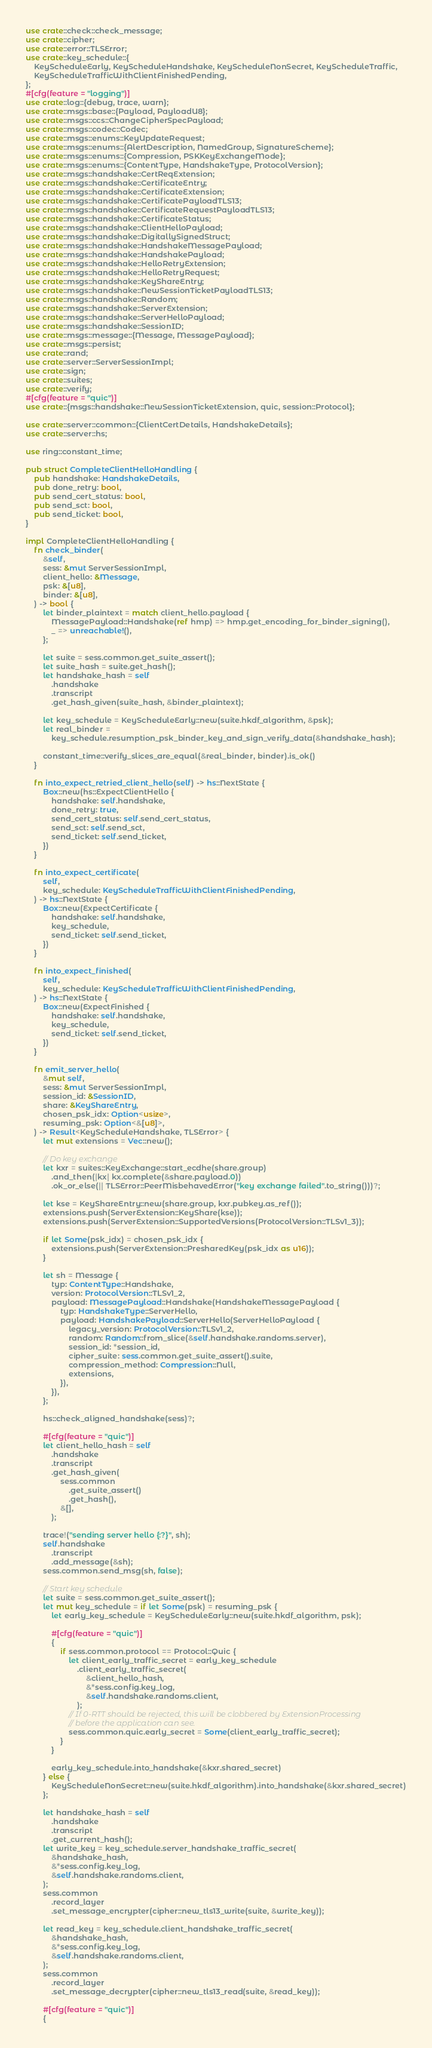Convert code to text. <code><loc_0><loc_0><loc_500><loc_500><_Rust_>use crate::check::check_message;
use crate::cipher;
use crate::error::TLSError;
use crate::key_schedule::{
    KeyScheduleEarly, KeyScheduleHandshake, KeyScheduleNonSecret, KeyScheduleTraffic,
    KeyScheduleTrafficWithClientFinishedPending,
};
#[cfg(feature = "logging")]
use crate::log::{debug, trace, warn};
use crate::msgs::base::{Payload, PayloadU8};
use crate::msgs::ccs::ChangeCipherSpecPayload;
use crate::msgs::codec::Codec;
use crate::msgs::enums::KeyUpdateRequest;
use crate::msgs::enums::{AlertDescription, NamedGroup, SignatureScheme};
use crate::msgs::enums::{Compression, PSKKeyExchangeMode};
use crate::msgs::enums::{ContentType, HandshakeType, ProtocolVersion};
use crate::msgs::handshake::CertReqExtension;
use crate::msgs::handshake::CertificateEntry;
use crate::msgs::handshake::CertificateExtension;
use crate::msgs::handshake::CertificatePayloadTLS13;
use crate::msgs::handshake::CertificateRequestPayloadTLS13;
use crate::msgs::handshake::CertificateStatus;
use crate::msgs::handshake::ClientHelloPayload;
use crate::msgs::handshake::DigitallySignedStruct;
use crate::msgs::handshake::HandshakeMessagePayload;
use crate::msgs::handshake::HandshakePayload;
use crate::msgs::handshake::HelloRetryExtension;
use crate::msgs::handshake::HelloRetryRequest;
use crate::msgs::handshake::KeyShareEntry;
use crate::msgs::handshake::NewSessionTicketPayloadTLS13;
use crate::msgs::handshake::Random;
use crate::msgs::handshake::ServerExtension;
use crate::msgs::handshake::ServerHelloPayload;
use crate::msgs::handshake::SessionID;
use crate::msgs::message::{Message, MessagePayload};
use crate::msgs::persist;
use crate::rand;
use crate::server::ServerSessionImpl;
use crate::sign;
use crate::suites;
use crate::verify;
#[cfg(feature = "quic")]
use crate::{msgs::handshake::NewSessionTicketExtension, quic, session::Protocol};

use crate::server::common::{ClientCertDetails, HandshakeDetails};
use crate::server::hs;

use ring::constant_time;

pub struct CompleteClientHelloHandling {
    pub handshake: HandshakeDetails,
    pub done_retry: bool,
    pub send_cert_status: bool,
    pub send_sct: bool,
    pub send_ticket: bool,
}

impl CompleteClientHelloHandling {
    fn check_binder(
        &self,
        sess: &mut ServerSessionImpl,
        client_hello: &Message,
        psk: &[u8],
        binder: &[u8],
    ) -> bool {
        let binder_plaintext = match client_hello.payload {
            MessagePayload::Handshake(ref hmp) => hmp.get_encoding_for_binder_signing(),
            _ => unreachable!(),
        };

        let suite = sess.common.get_suite_assert();
        let suite_hash = suite.get_hash();
        let handshake_hash = self
            .handshake
            .transcript
            .get_hash_given(suite_hash, &binder_plaintext);

        let key_schedule = KeyScheduleEarly::new(suite.hkdf_algorithm, &psk);
        let real_binder =
            key_schedule.resumption_psk_binder_key_and_sign_verify_data(&handshake_hash);

        constant_time::verify_slices_are_equal(&real_binder, binder).is_ok()
    }

    fn into_expect_retried_client_hello(self) -> hs::NextState {
        Box::new(hs::ExpectClientHello {
            handshake: self.handshake,
            done_retry: true,
            send_cert_status: self.send_cert_status,
            send_sct: self.send_sct,
            send_ticket: self.send_ticket,
        })
    }

    fn into_expect_certificate(
        self,
        key_schedule: KeyScheduleTrafficWithClientFinishedPending,
    ) -> hs::NextState {
        Box::new(ExpectCertificate {
            handshake: self.handshake,
            key_schedule,
            send_ticket: self.send_ticket,
        })
    }

    fn into_expect_finished(
        self,
        key_schedule: KeyScheduleTrafficWithClientFinishedPending,
    ) -> hs::NextState {
        Box::new(ExpectFinished {
            handshake: self.handshake,
            key_schedule,
            send_ticket: self.send_ticket,
        })
    }

    fn emit_server_hello(
        &mut self,
        sess: &mut ServerSessionImpl,
        session_id: &SessionID,
        share: &KeyShareEntry,
        chosen_psk_idx: Option<usize>,
        resuming_psk: Option<&[u8]>,
    ) -> Result<KeyScheduleHandshake, TLSError> {
        let mut extensions = Vec::new();

        // Do key exchange
        let kxr = suites::KeyExchange::start_ecdhe(share.group)
            .and_then(|kx| kx.complete(&share.payload.0))
            .ok_or_else(|| TLSError::PeerMisbehavedError("key exchange failed".to_string()))?;

        let kse = KeyShareEntry::new(share.group, kxr.pubkey.as_ref());
        extensions.push(ServerExtension::KeyShare(kse));
        extensions.push(ServerExtension::SupportedVersions(ProtocolVersion::TLSv1_3));

        if let Some(psk_idx) = chosen_psk_idx {
            extensions.push(ServerExtension::PresharedKey(psk_idx as u16));
        }

        let sh = Message {
            typ: ContentType::Handshake,
            version: ProtocolVersion::TLSv1_2,
            payload: MessagePayload::Handshake(HandshakeMessagePayload {
                typ: HandshakeType::ServerHello,
                payload: HandshakePayload::ServerHello(ServerHelloPayload {
                    legacy_version: ProtocolVersion::TLSv1_2,
                    random: Random::from_slice(&self.handshake.randoms.server),
                    session_id: *session_id,
                    cipher_suite: sess.common.get_suite_assert().suite,
                    compression_method: Compression::Null,
                    extensions,
                }),
            }),
        };

        hs::check_aligned_handshake(sess)?;

        #[cfg(feature = "quic")]
        let client_hello_hash = self
            .handshake
            .transcript
            .get_hash_given(
                sess.common
                    .get_suite_assert()
                    .get_hash(),
                &[],
            );

        trace!("sending server hello {:?}", sh);
        self.handshake
            .transcript
            .add_message(&sh);
        sess.common.send_msg(sh, false);

        // Start key schedule
        let suite = sess.common.get_suite_assert();
        let mut key_schedule = if let Some(psk) = resuming_psk {
            let early_key_schedule = KeyScheduleEarly::new(suite.hkdf_algorithm, psk);

            #[cfg(feature = "quic")]
            {
                if sess.common.protocol == Protocol::Quic {
                    let client_early_traffic_secret = early_key_schedule
                        .client_early_traffic_secret(
                            &client_hello_hash,
                            &*sess.config.key_log,
                            &self.handshake.randoms.client,
                        );
                    // If 0-RTT should be rejected, this will be clobbered by ExtensionProcessing
                    // before the application can see.
                    sess.common.quic.early_secret = Some(client_early_traffic_secret);
                }
            }

            early_key_schedule.into_handshake(&kxr.shared_secret)
        } else {
            KeyScheduleNonSecret::new(suite.hkdf_algorithm).into_handshake(&kxr.shared_secret)
        };

        let handshake_hash = self
            .handshake
            .transcript
            .get_current_hash();
        let write_key = key_schedule.server_handshake_traffic_secret(
            &handshake_hash,
            &*sess.config.key_log,
            &self.handshake.randoms.client,
        );
        sess.common
            .record_layer
            .set_message_encrypter(cipher::new_tls13_write(suite, &write_key));

        let read_key = key_schedule.client_handshake_traffic_secret(
            &handshake_hash,
            &*sess.config.key_log,
            &self.handshake.randoms.client,
        );
        sess.common
            .record_layer
            .set_message_decrypter(cipher::new_tls13_read(suite, &read_key));

        #[cfg(feature = "quic")]
        {</code> 